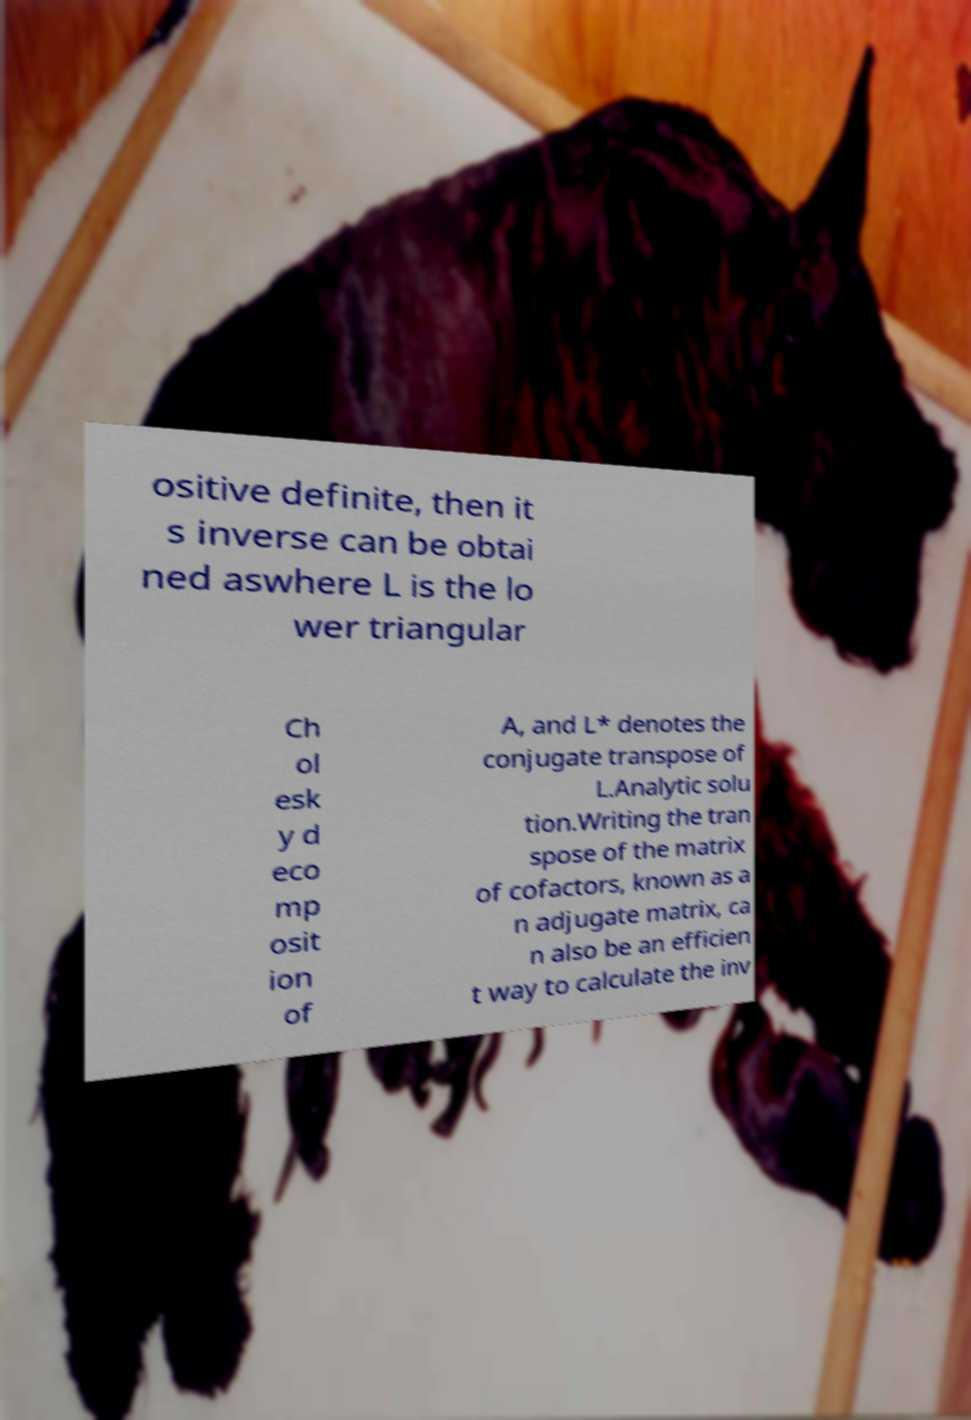There's text embedded in this image that I need extracted. Can you transcribe it verbatim? ositive definite, then it s inverse can be obtai ned aswhere L is the lo wer triangular Ch ol esk y d eco mp osit ion of A, and L* denotes the conjugate transpose of L.Analytic solu tion.Writing the tran spose of the matrix of cofactors, known as a n adjugate matrix, ca n also be an efficien t way to calculate the inv 